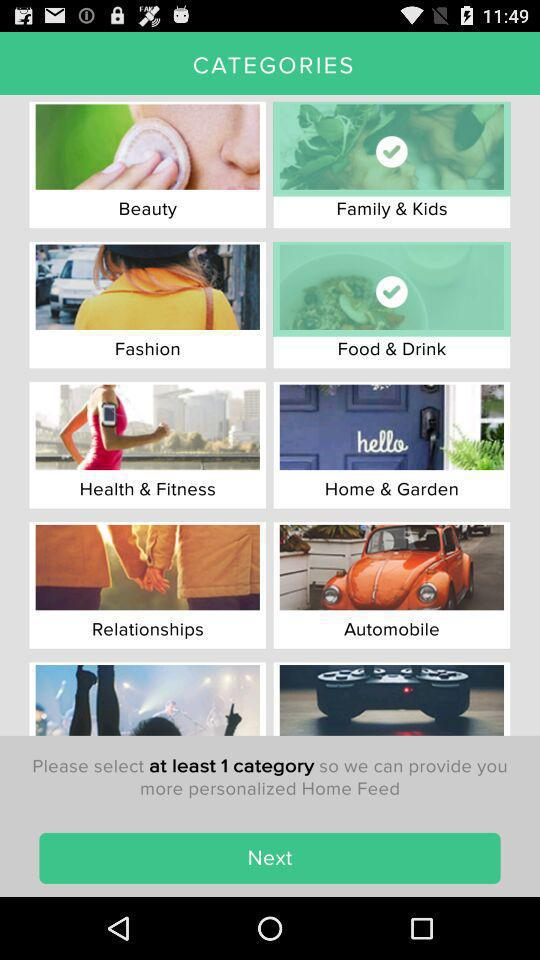Which are the selected categories? The selected categories are "Family & Kids" and "Food & Drink". 